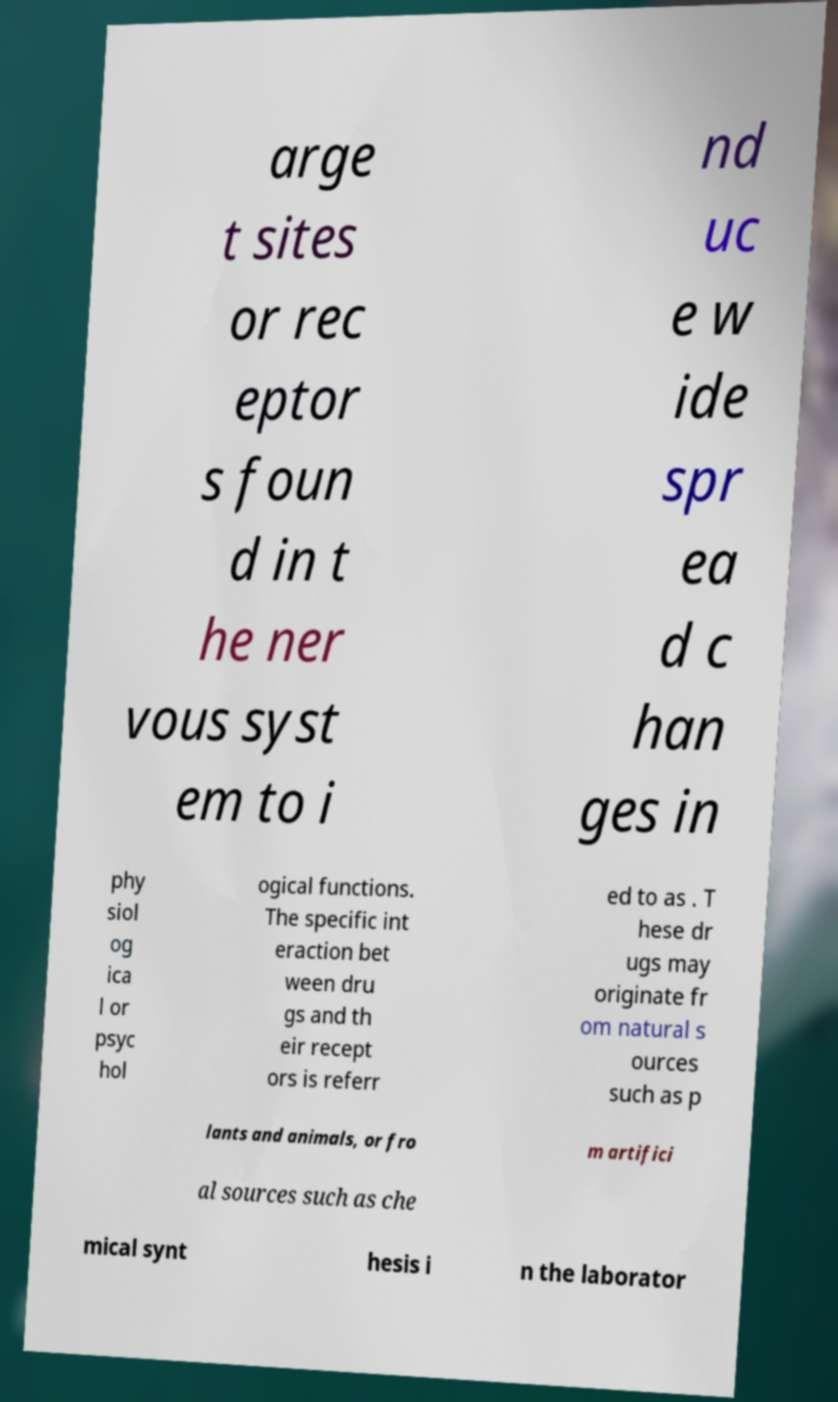What messages or text are displayed in this image? I need them in a readable, typed format. arge t sites or rec eptor s foun d in t he ner vous syst em to i nd uc e w ide spr ea d c han ges in phy siol og ica l or psyc hol ogical functions. The specific int eraction bet ween dru gs and th eir recept ors is referr ed to as . T hese dr ugs may originate fr om natural s ources such as p lants and animals, or fro m artifici al sources such as che mical synt hesis i n the laborator 